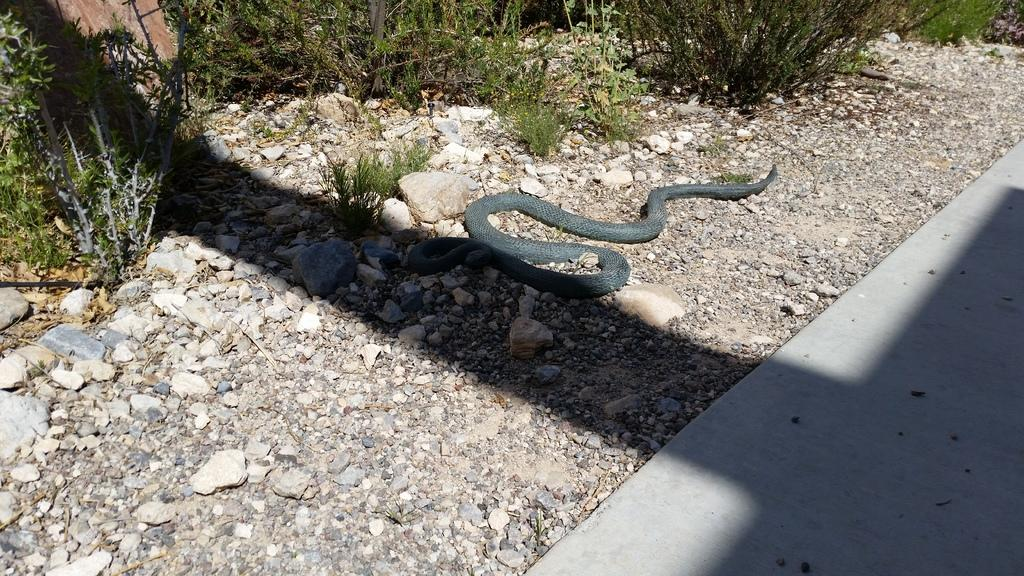What type of living organisms can be seen in the image? Plants can be seen in the image. What animal is present in the image? There is a snake in the middle of the image. How many dogs are participating in the show in the image? There are no dogs or shows present in the image; it features plants and a snake. 